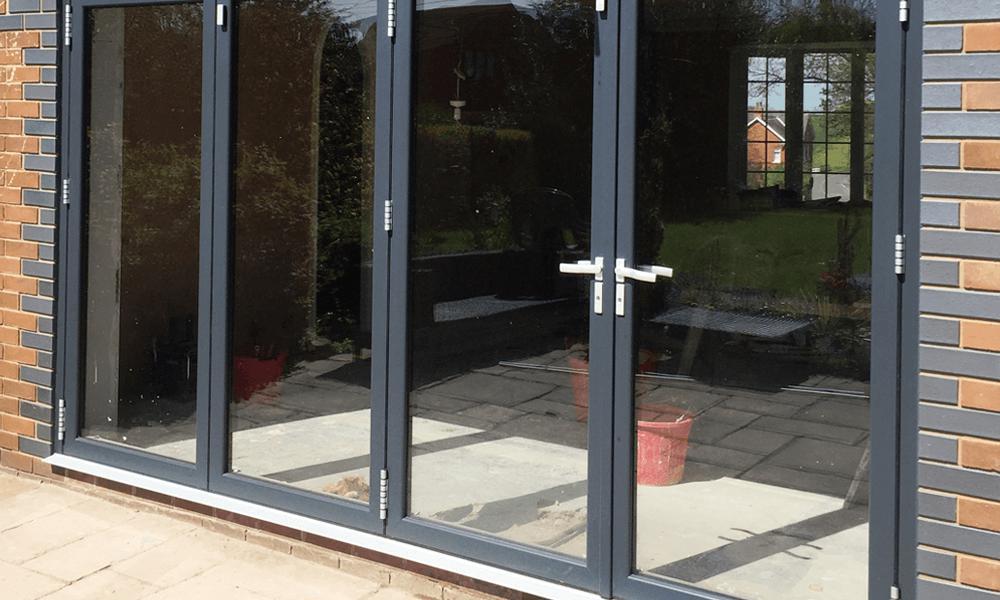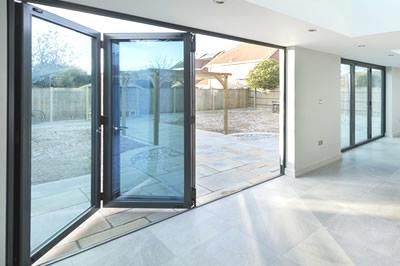The first image is the image on the left, the second image is the image on the right. For the images shown, is this caption "The doors in the left image are closed." true? Answer yes or no. Yes. The first image is the image on the left, the second image is the image on the right. Assess this claim about the two images: "An image shows a glass door unit with at least three panels and with a handle on the rightmost door, flanked by bricks of different colors and viewed at an angle.". Correct or not? Answer yes or no. Yes. 